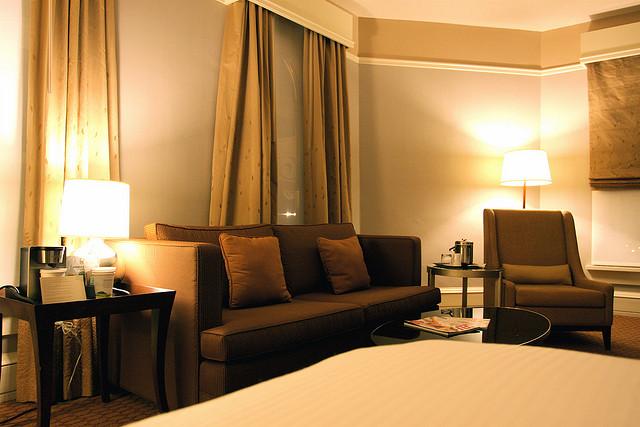Is this a hotel room?
Give a very brief answer. Yes. What wattage light bulbs are in the lamps?
Write a very short answer. 60. What shape is the pillow in the chair?
Answer briefly. Square. 